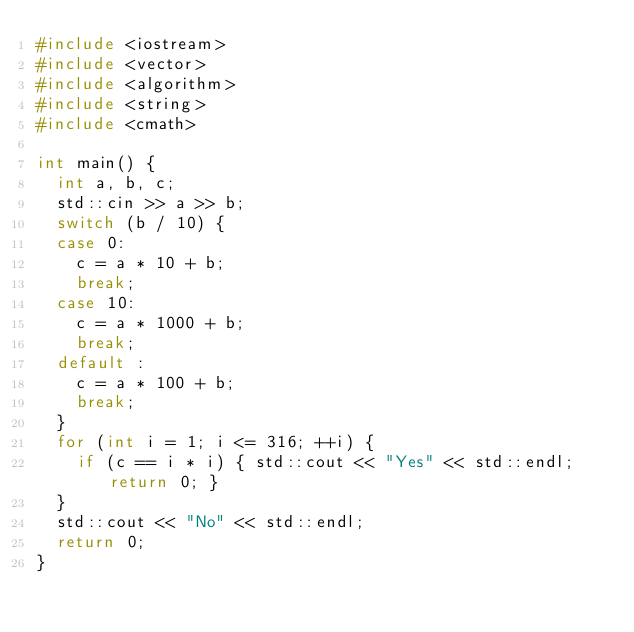Convert code to text. <code><loc_0><loc_0><loc_500><loc_500><_C++_>#include <iostream>
#include <vector>
#include <algorithm>
#include <string>
#include <cmath>

int main() {
	int a, b, c;
	std::cin >> a >> b;
	switch (b / 10) {
	case 0:
		c = a * 10 + b;
		break;
	case 10:
		c = a * 1000 + b;
		break;
	default :
		c = a * 100 + b;
		break;
	}
	for (int i = 1; i <= 316; ++i) {
		if (c == i * i) { std::cout << "Yes" << std::endl; return 0; }
	}
	std::cout << "No" << std::endl;
	return 0;
}</code> 